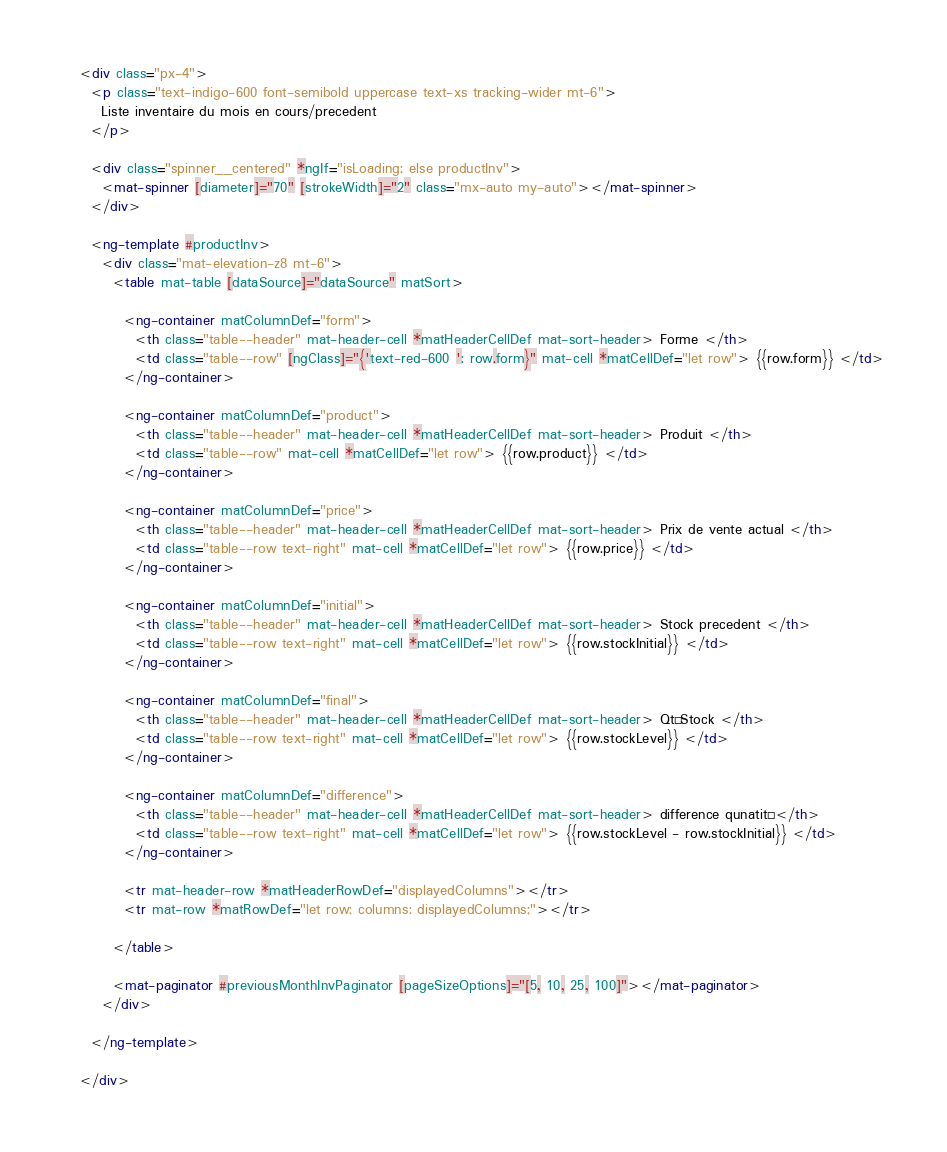Convert code to text. <code><loc_0><loc_0><loc_500><loc_500><_HTML_><div class="px-4">
  <p class="text-indigo-600 font-semibold uppercase text-xs tracking-wider mt-6">
    Liste inventaire du mois en cours/precedent
  </p>

  <div class="spinner__centered" *ngIf="isLoading; else productInv">
    <mat-spinner [diameter]="70" [strokeWidth]="2" class="mx-auto my-auto"></mat-spinner>
  </div>

  <ng-template #productInv>
    <div class="mat-elevation-z8 mt-6">
      <table mat-table [dataSource]="dataSource" matSort>

        <ng-container matColumnDef="form">
          <th class="table--header" mat-header-cell *matHeaderCellDef mat-sort-header> Forme </th>
          <td class="table--row" [ngClass]="{'text-red-600 ': row.form}" mat-cell *matCellDef="let row"> {{row.form}} </td>
        </ng-container>

        <ng-container matColumnDef="product">
          <th class="table--header" mat-header-cell *matHeaderCellDef mat-sort-header> Produit </th>
          <td class="table--row" mat-cell *matCellDef="let row"> {{row.product}} </td>
        </ng-container>

        <ng-container matColumnDef="price">
          <th class="table--header" mat-header-cell *matHeaderCellDef mat-sort-header> Prix de vente actual </th>
          <td class="table--row text-right" mat-cell *matCellDef="let row"> {{row.price}} </td>
        </ng-container>

        <ng-container matColumnDef="initial">
          <th class="table--header" mat-header-cell *matHeaderCellDef mat-sort-header> Stock precedent </th>
          <td class="table--row text-right" mat-cell *matCellDef="let row"> {{row.stockInitial}} </td>
        </ng-container>

        <ng-container matColumnDef="final">
          <th class="table--header" mat-header-cell *matHeaderCellDef mat-sort-header> Qté Stock </th>
          <td class="table--row text-right" mat-cell *matCellDef="let row"> {{row.stockLevel}} </td>
        </ng-container>

        <ng-container matColumnDef="difference">
          <th class="table--header" mat-header-cell *matHeaderCellDef mat-sort-header> difference qunatité </th>
          <td class="table--row text-right" mat-cell *matCellDef="let row"> {{row.stockLevel - row.stockInitial}} </td>
        </ng-container>

        <tr mat-header-row *matHeaderRowDef="displayedColumns"></tr>
        <tr mat-row *matRowDef="let row; columns: displayedColumns;"></tr>

      </table>

      <mat-paginator #previousMonthInvPaginator [pageSizeOptions]="[5, 10, 25, 100]"></mat-paginator>
    </div>

  </ng-template>

</div>
</code> 